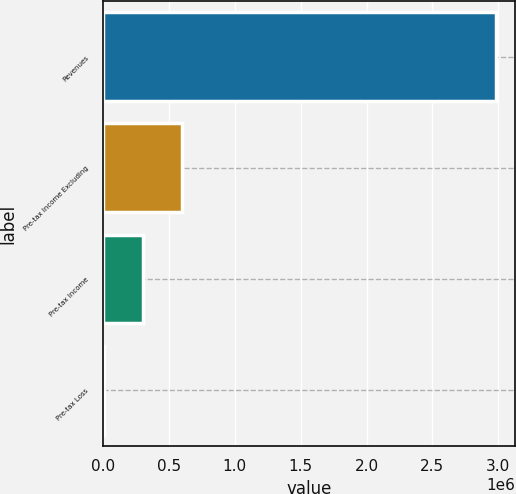Convert chart. <chart><loc_0><loc_0><loc_500><loc_500><bar_chart><fcel>Revenues<fcel>Pre-tax Income Excluding<fcel>Pre-tax Income<fcel>Pre-tax Loss<nl><fcel>2.97952e+06<fcel>600260<fcel>302853<fcel>5446<nl></chart> 